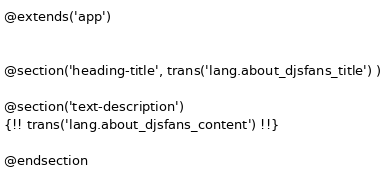Convert code to text. <code><loc_0><loc_0><loc_500><loc_500><_PHP_>@extends('app')


@section('heading-title', trans('lang.about_djsfans_title') )

@section('text-description')
{!! trans('lang.about_djsfans_content') !!}   

@endsection
</code> 